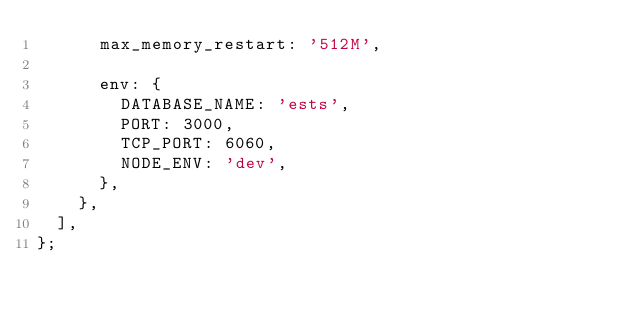Convert code to text. <code><loc_0><loc_0><loc_500><loc_500><_JavaScript_>      max_memory_restart: '512M',

      env: {
        DATABASE_NAME: 'ests',
        PORT: 3000,
        TCP_PORT: 6060,
        NODE_ENV: 'dev',
      },
    },
  ],
};
</code> 